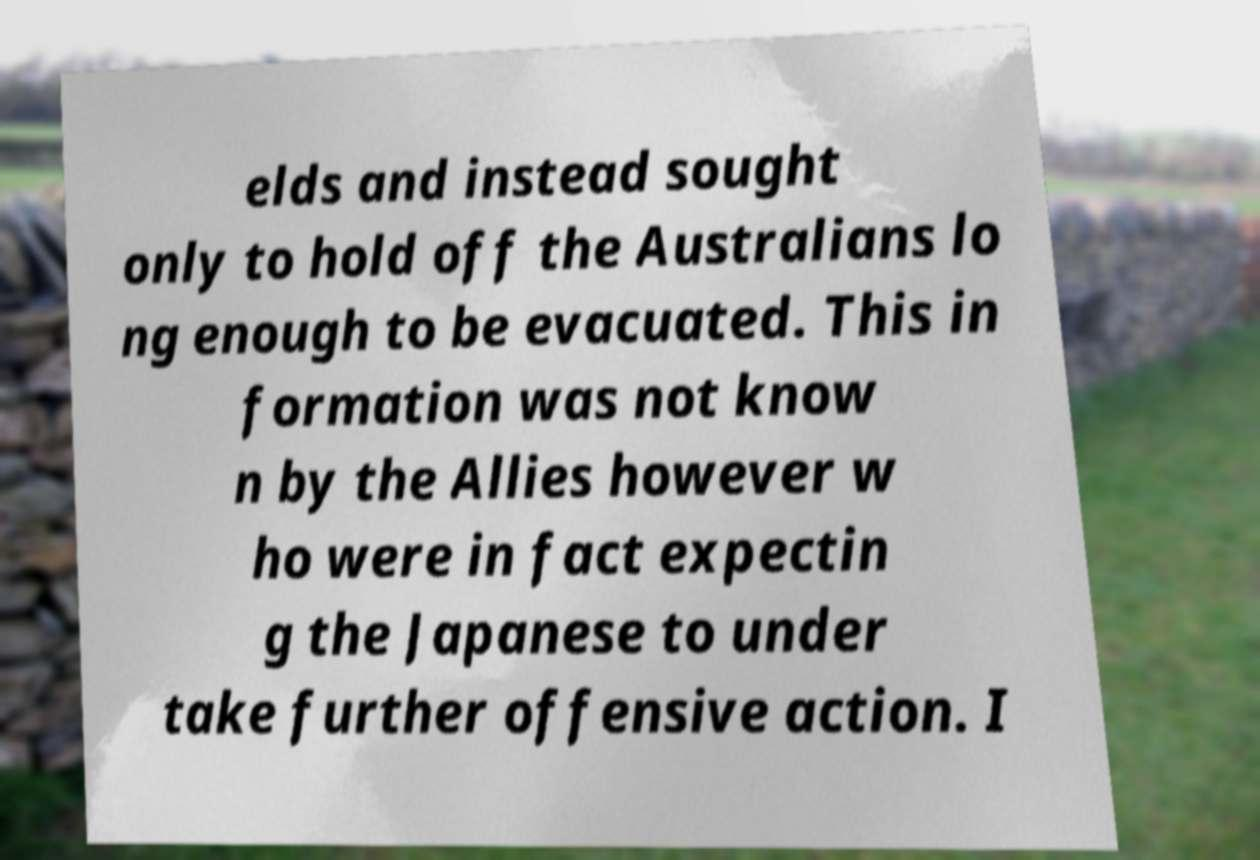Could you extract and type out the text from this image? elds and instead sought only to hold off the Australians lo ng enough to be evacuated. This in formation was not know n by the Allies however w ho were in fact expectin g the Japanese to under take further offensive action. I 